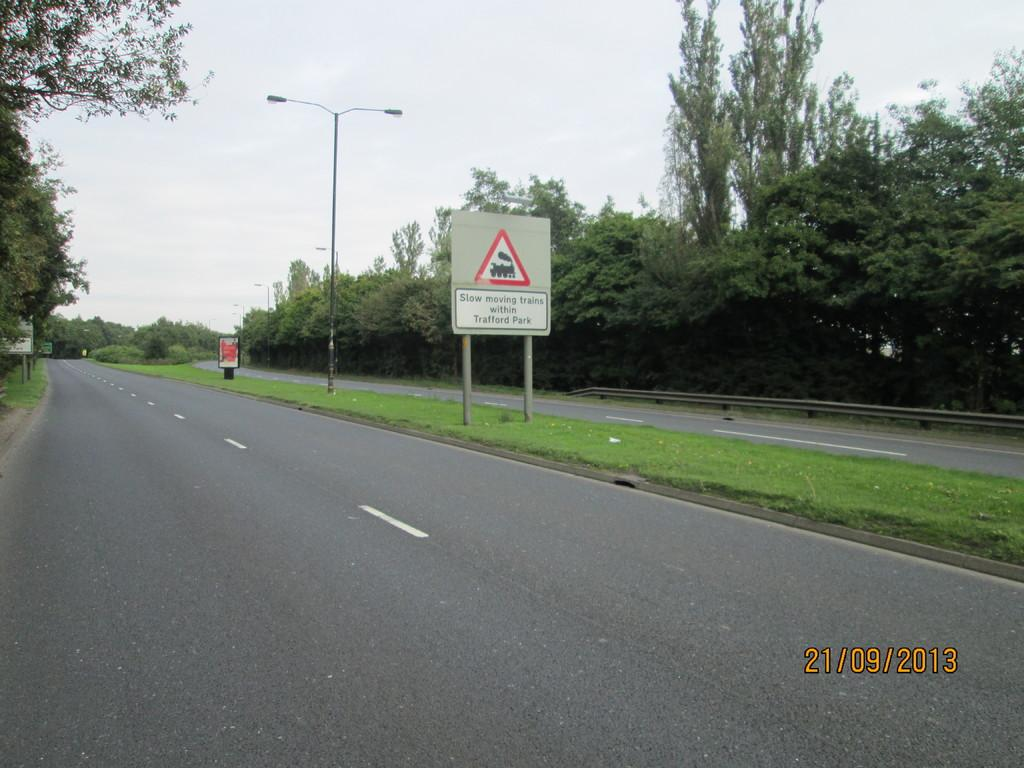Provide a one-sentence caption for the provided image. A sign next to a road that says "Slow moving trains within Trafford Park.". 